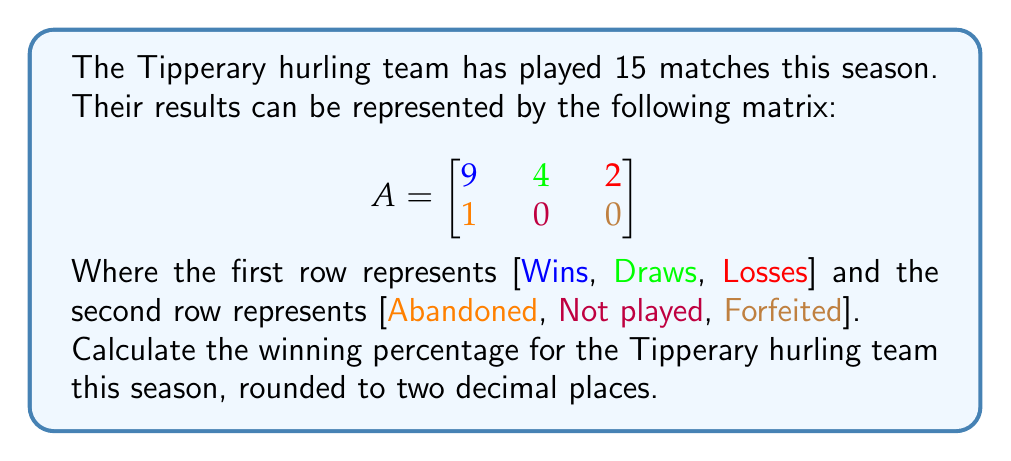Show me your answer to this math problem. Let's approach this step-by-step:

1) First, we need to calculate the total number of games that count towards the winning percentage. This includes wins, draws, and losses.

   Total games = Wins + Draws + Losses
   $$ 9 + 4 + 2 = 15 $$

2) In hurling, draws are typically counted as half a win. So we need to calculate the equivalent number of wins:

   Equivalent wins = Wins + (0.5 × Draws)
   $$ 9 + (0.5 \times 4) = 9 + 2 = 11 $$

3) Now we can calculate the winning percentage:

   Winning Percentage = $\frac{\text{Equivalent Wins}}{\text{Total Games}} \times 100\%$

   $$ \frac{11}{15} \times 100\% = 0.7333... \times 100\% = 73.33\% $$

4) Rounding to two decimal places:

   $$ 73.33\% $$
Answer: 73.33% 